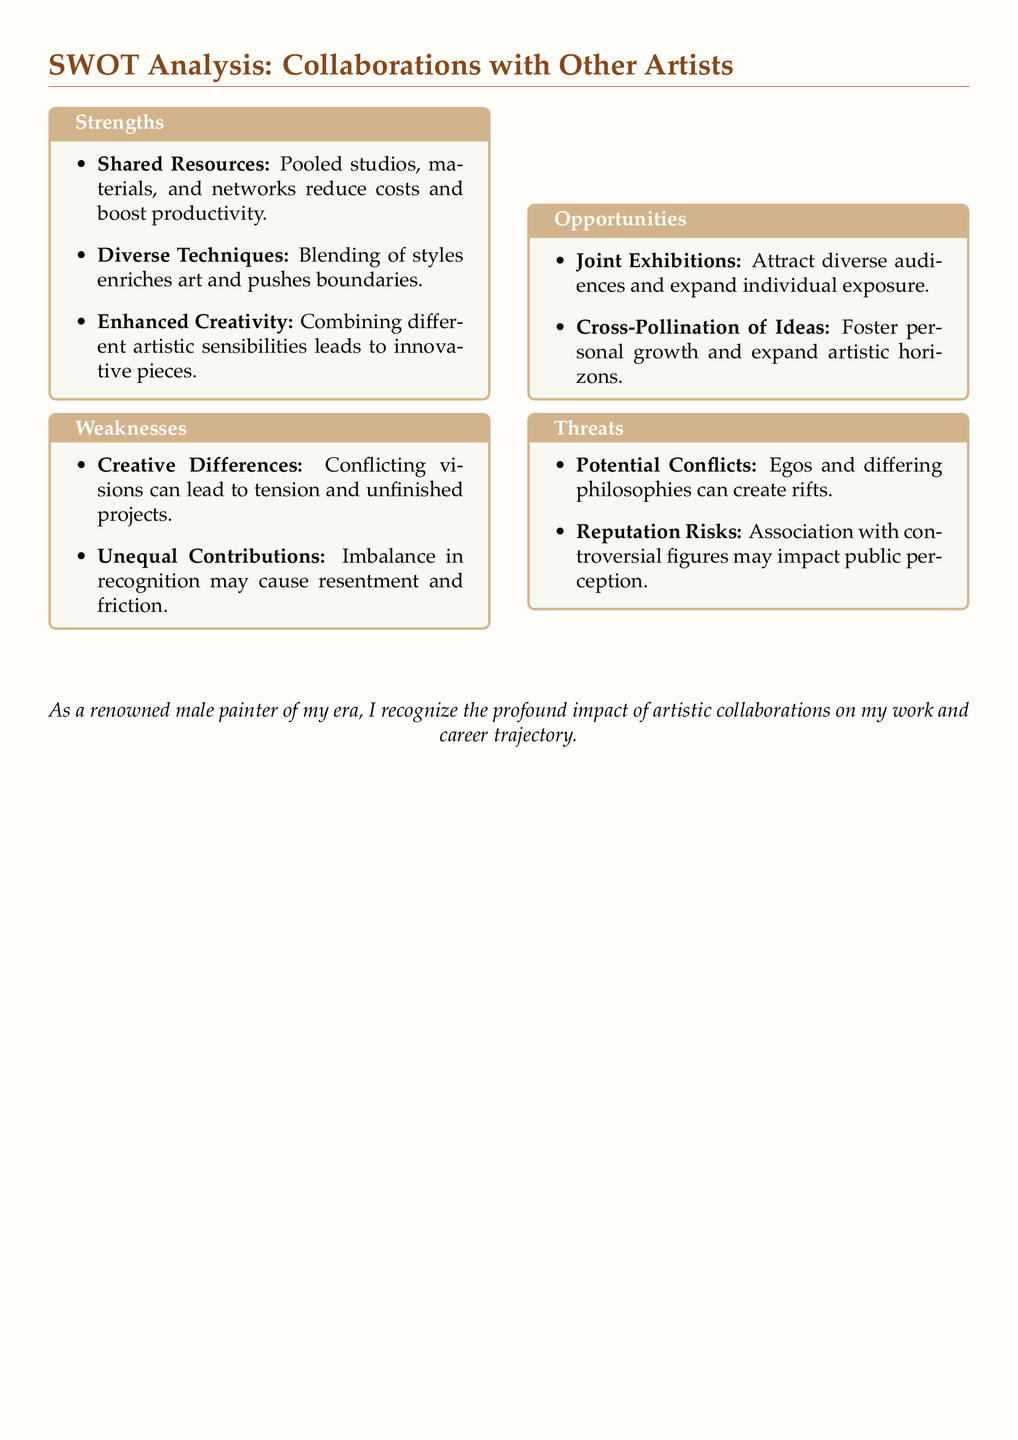What are the strengths of collaborations with other artists? The strengths are detailed in the document under the "Strengths" section, which includes shared resources, diverse techniques, and enhanced creativity.
Answer: Shared Resources, Diverse Techniques, Enhanced Creativity What weakness relates to creative differences? The document mentions "Creative Differences" as a weakness under the "Weaknesses" section, highlighting the potential for tension and unfinished projects.
Answer: Creative Differences What opportunity is related to audience expansion? The document lists "Joint Exhibitions" as an opportunity that can attract diverse audiences and expand individual exposure.
Answer: Joint Exhibitions What are the threats associated with reputational risks? The document notes "Reputation Risks" under the "Threats" section, indicating the potential impact of associations with controversial figures on public perception.
Answer: Reputation Risks How many strengths are mentioned in the analysis? The document presents three specific strengths in the "Strengths" section related to collaborations with other artists.
Answer: Three What is the consequence of unequal contributions? The document states that unequal contributions can cause resentment and friction, which is classified as a weakness.
Answer: Resentment and friction What type of risk involves conflicting philosophical views? The document describes "Potential Conflicts" as a threat, originating from differing philosophies and egos among artists.
Answer: Potential Conflicts What does the analysis suggest about artistic growth? The document indicates "Cross-Pollination of Ideas" as an opportunity that can foster personal growth and expand artistic horizons.
Answer: Cross-Pollination of Ideas What aspect of collaboration can enhance creativity? The document attributes "Enhanced Creativity" as part of the strengths gained from combining different artistic sensibilities in collaboration.
Answer: Enhanced Creativity 